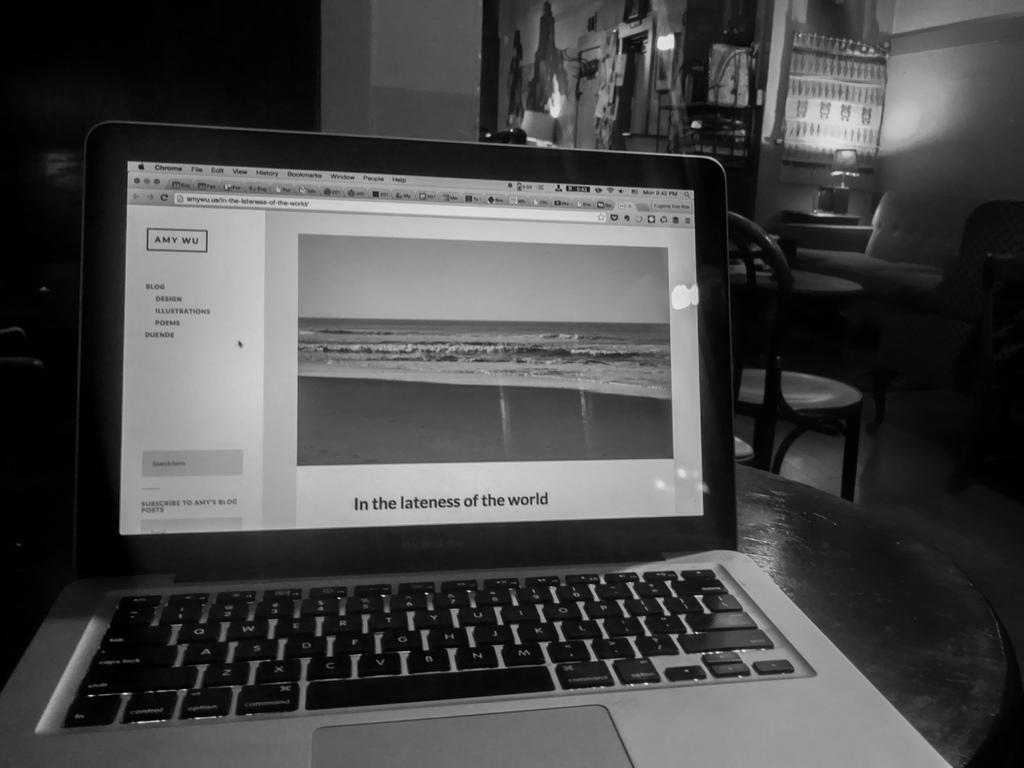<image>
Relay a brief, clear account of the picture shown. A laptop displays a photo captioned with "In the lateness of the world". 